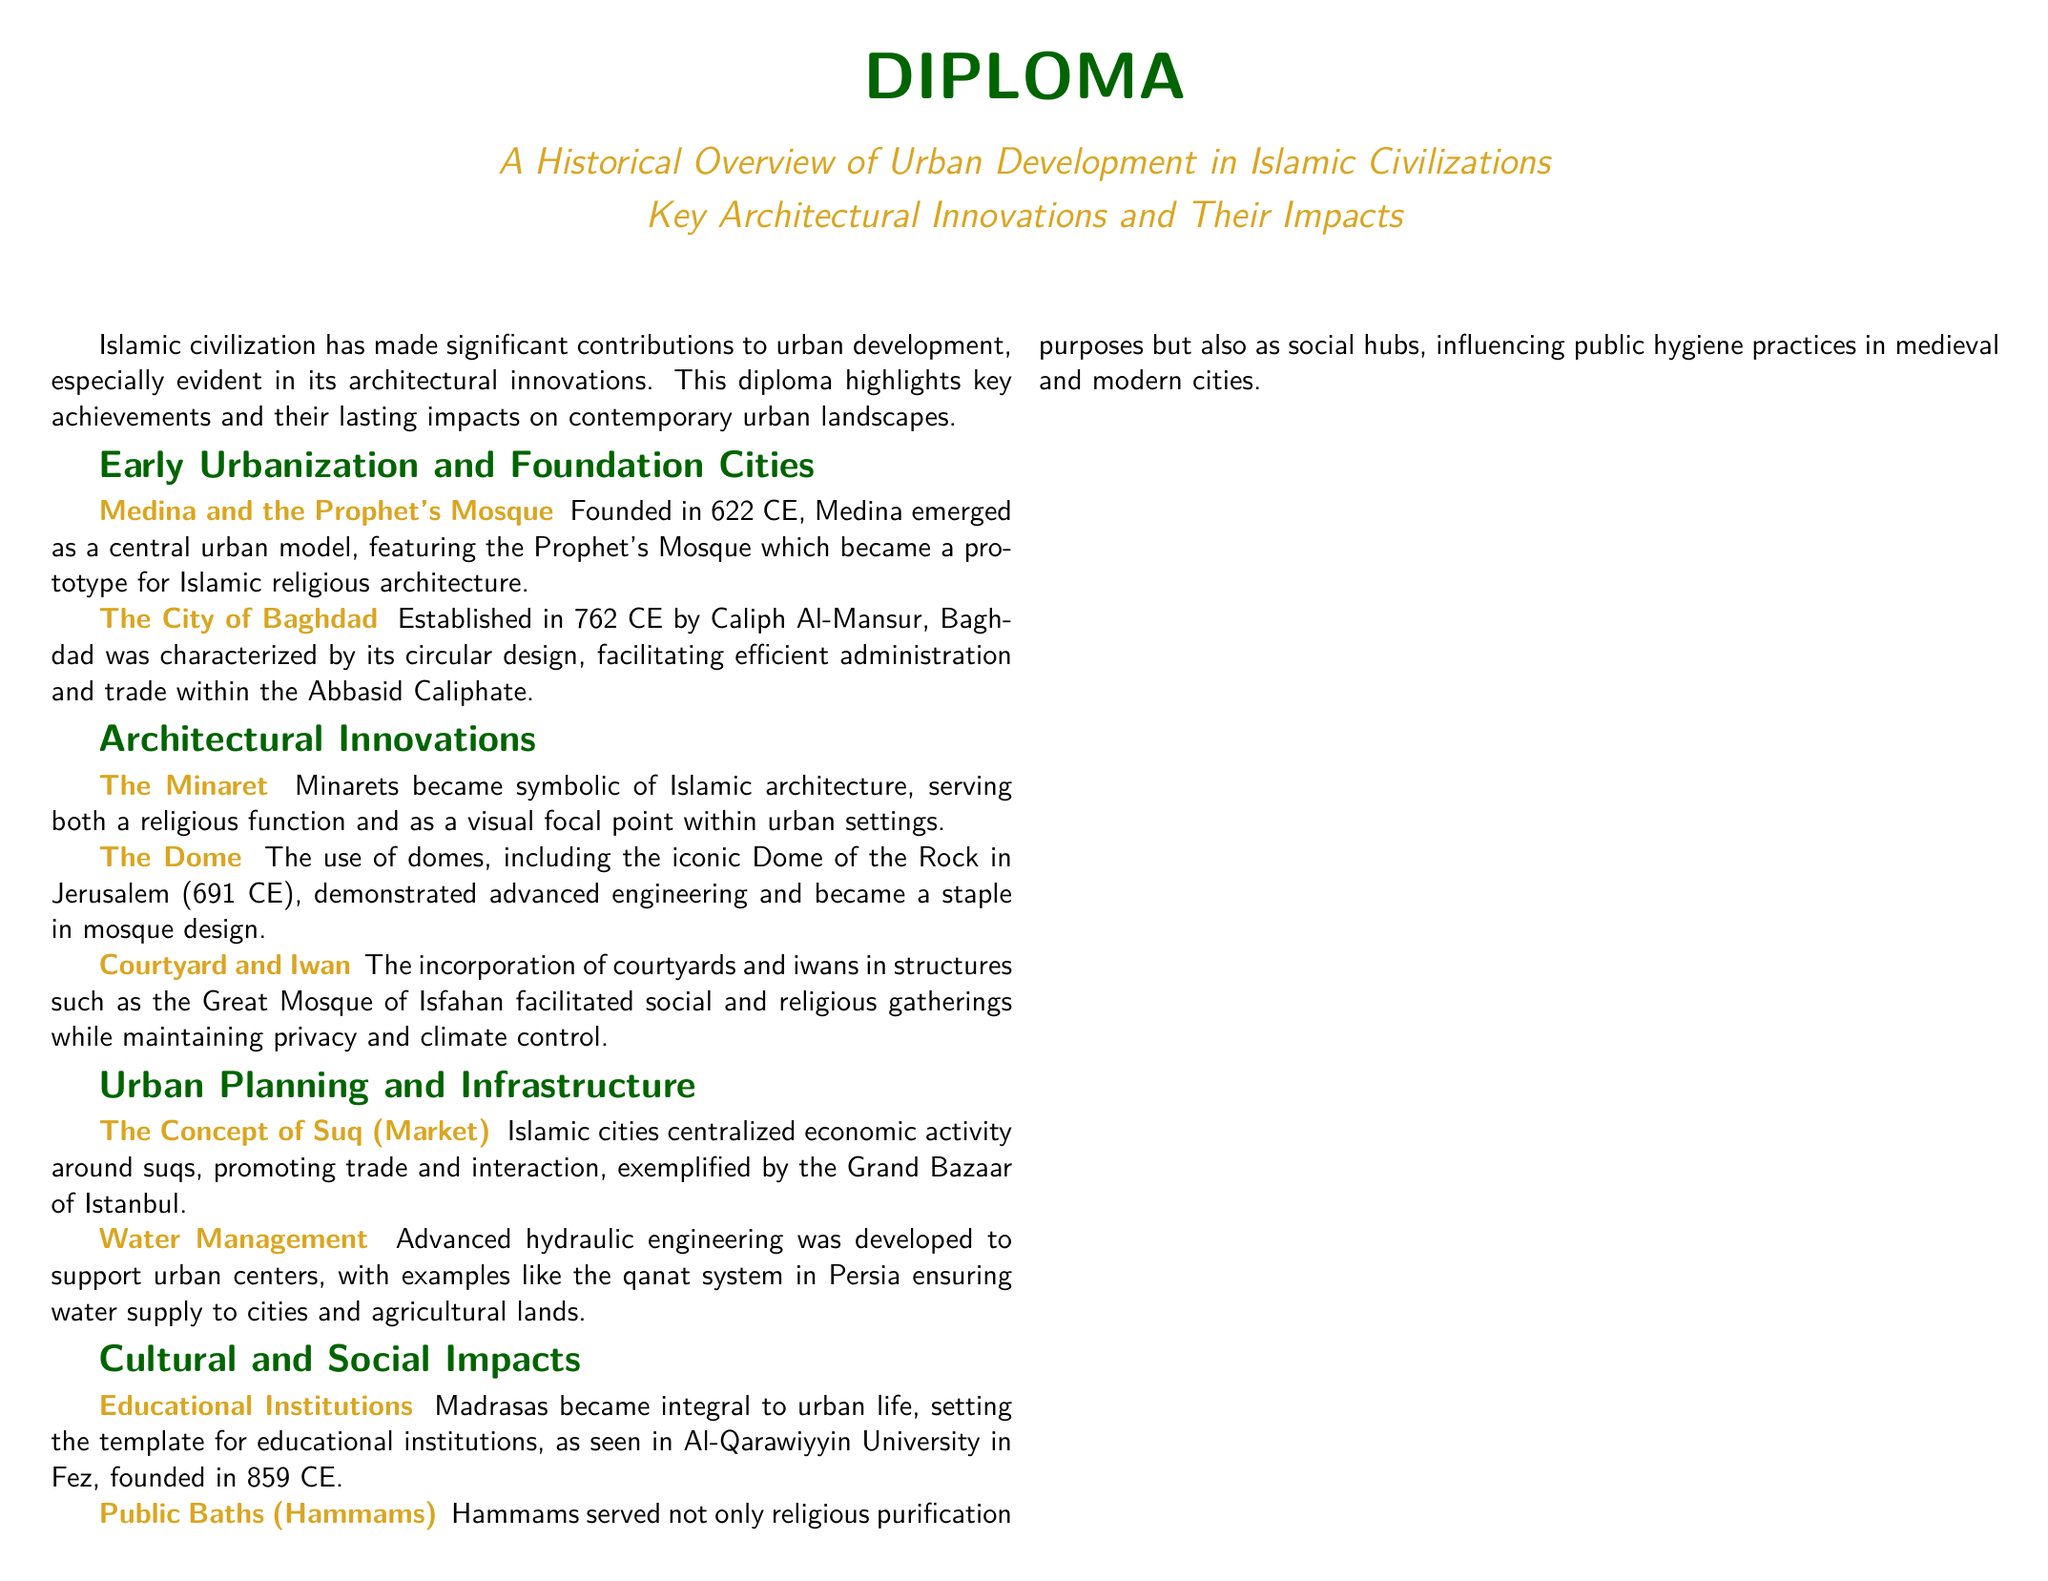What year was Medina founded? Medina was founded in 622 CE, as stated in the document.
Answer: 622 CE Who established the city of Baghdad? The document mentions that Caliph Al-Mansur established Baghdad in 762 CE.
Answer: Caliph Al-Mansur What architectural feature became symbolic of Islamic architecture? The document identifies the minaret as a symbolic feature of Islamic architecture.
Answer: Minaret What is a key example of advanced hydraulic engineering mentioned? The qanat system in Persia is referenced as an advanced hydraulic engineering example.
Answer: Qanat system In what year was Al-Qarawiyyin University founded? The document states that Al-Qarawiyyin University was founded in 859 CE.
Answer: 859 CE What role did hammams serve in Islamic cities? The document describes hammams as both religious purification centers and social hubs.
Answer: Social hubs What concept centralized economic activity in Islamic cities? The document discusses the concept of the suq as central to economic activity.
Answer: Suq Which mosque features the iconic Dome of the Rock? The Dome of the Rock is located in Jerusalem, as mentioned in the document.
Answer: Jerusalem What was a significant impact of courtyard and iwan incorporation in structures? The document states that courtyards and iwans facilitated social and religious gatherings.
Answer: Social and religious gatherings 